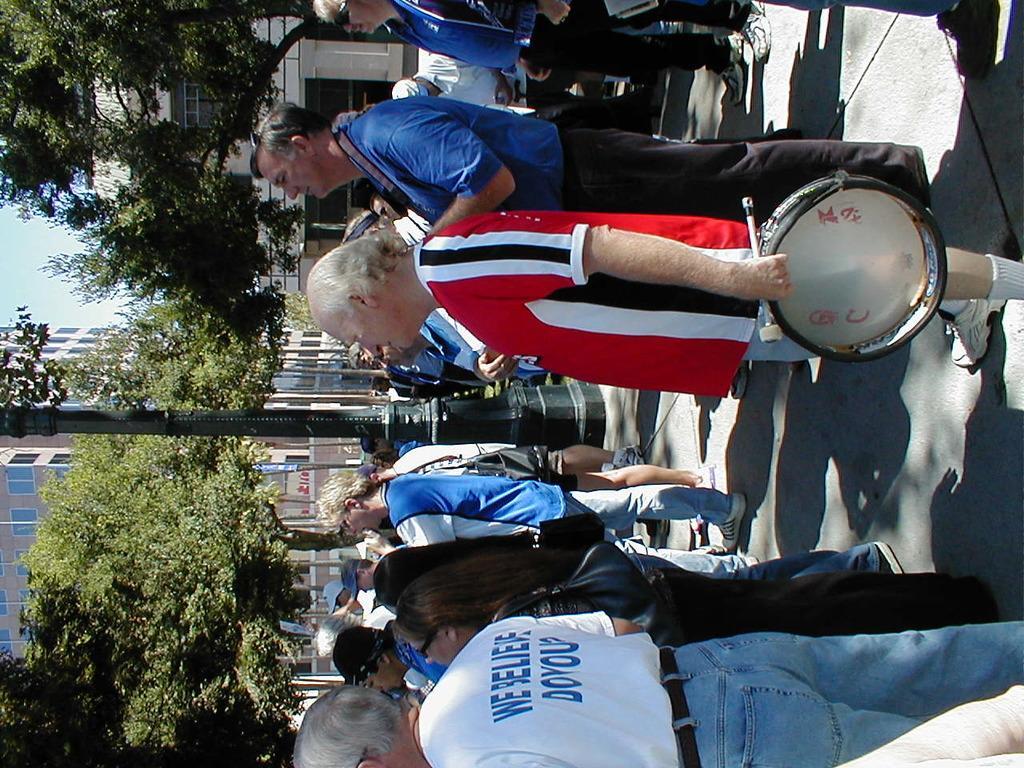Could you give a brief overview of what you see in this image? In this image there are group of people standing , one man standing catching drums, another man standing beside him , at the back ground there are trees, building, pole , name board. 